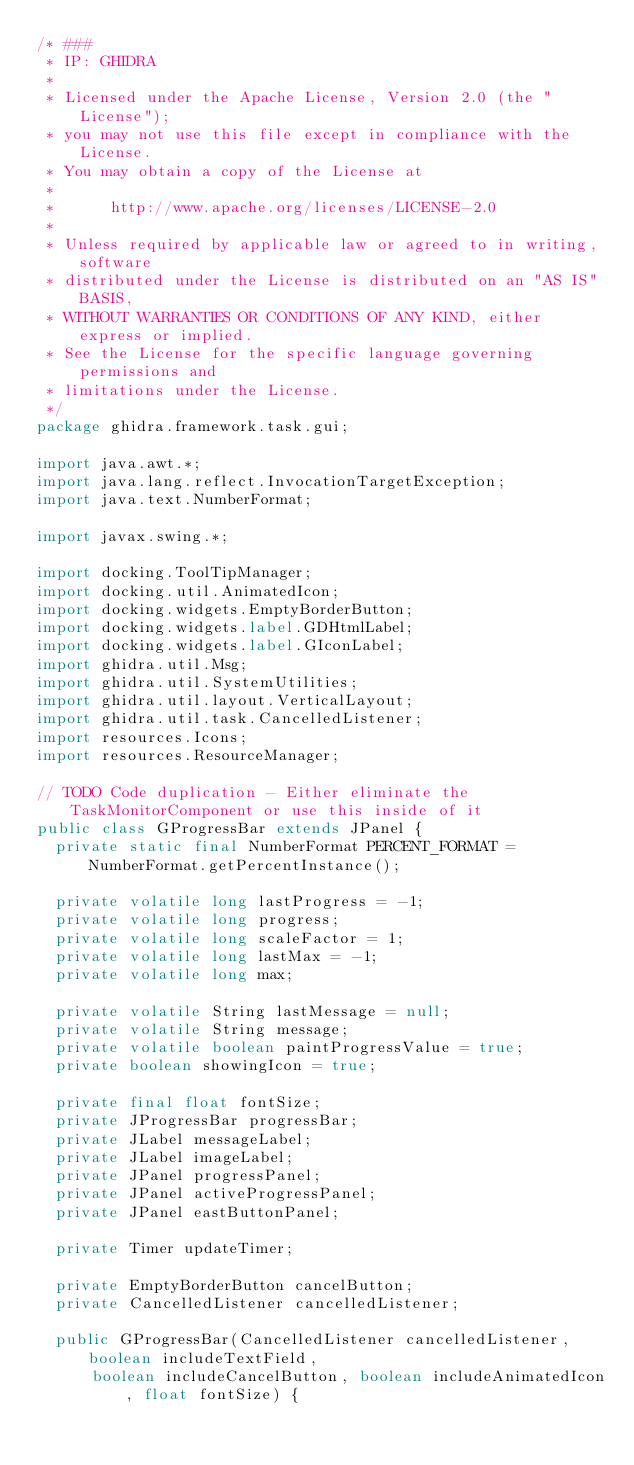<code> <loc_0><loc_0><loc_500><loc_500><_Java_>/* ###
 * IP: GHIDRA
 *
 * Licensed under the Apache License, Version 2.0 (the "License");
 * you may not use this file except in compliance with the License.
 * You may obtain a copy of the License at
 * 
 *      http://www.apache.org/licenses/LICENSE-2.0
 * 
 * Unless required by applicable law or agreed to in writing, software
 * distributed under the License is distributed on an "AS IS" BASIS,
 * WITHOUT WARRANTIES OR CONDITIONS OF ANY KIND, either express or implied.
 * See the License for the specific language governing permissions and
 * limitations under the License.
 */
package ghidra.framework.task.gui;

import java.awt.*;
import java.lang.reflect.InvocationTargetException;
import java.text.NumberFormat;

import javax.swing.*;

import docking.ToolTipManager;
import docking.util.AnimatedIcon;
import docking.widgets.EmptyBorderButton;
import docking.widgets.label.GDHtmlLabel;
import docking.widgets.label.GIconLabel;
import ghidra.util.Msg;
import ghidra.util.SystemUtilities;
import ghidra.util.layout.VerticalLayout;
import ghidra.util.task.CancelledListener;
import resources.Icons;
import resources.ResourceManager;

// TODO Code duplication - Either eliminate the TaskMonitorComponent or use this inside of it
public class GProgressBar extends JPanel {
	private static final NumberFormat PERCENT_FORMAT = NumberFormat.getPercentInstance();

	private volatile long lastProgress = -1;
	private volatile long progress;
	private volatile long scaleFactor = 1;
	private volatile long lastMax = -1;
	private volatile long max;

	private volatile String lastMessage = null;
	private volatile String message;
	private volatile boolean paintProgressValue = true;
	private boolean showingIcon = true;

	private final float fontSize;
	private JProgressBar progressBar;
	private JLabel messageLabel;
	private JLabel imageLabel;
	private JPanel progressPanel;
	private JPanel activeProgressPanel;
	private JPanel eastButtonPanel;

	private Timer updateTimer;

	private EmptyBorderButton cancelButton;
	private CancelledListener cancelledListener;

	public GProgressBar(CancelledListener cancelledListener, boolean includeTextField,
			boolean includeCancelButton, boolean includeAnimatedIcon, float fontSize) {</code> 